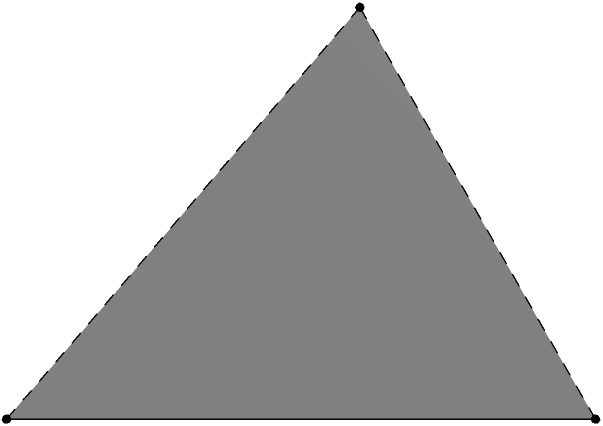During your tour guide expedition, you encounter an ancient pyramid-shaped monument. The base of the monument is a square with sides measuring 4 meters, and its height is 3 meters. What is the volume of this monument in cubic meters? To calculate the volume of a pyramid, we can use the formula:

$$V = \frac{1}{3} \times B \times h$$

Where:
$V$ = Volume
$B$ = Area of the base
$h$ = Height of the pyramid

Let's solve this step-by-step:

1) First, calculate the area of the square base:
   $B = 4m \times 4m = 16m^2$

2) Now, we have all the required information:
   $B = 16m^2$
   $h = 3m$

3) Let's plug these values into the formula:
   $$V = \frac{1}{3} \times 16m^2 \times 3m$$

4) Simplify:
   $$V = \frac{16 \times 3}{3}m^3 = 16m^3$$

Therefore, the volume of the pyramid-shaped monument is 16 cubic meters.
Answer: $16m^3$ 